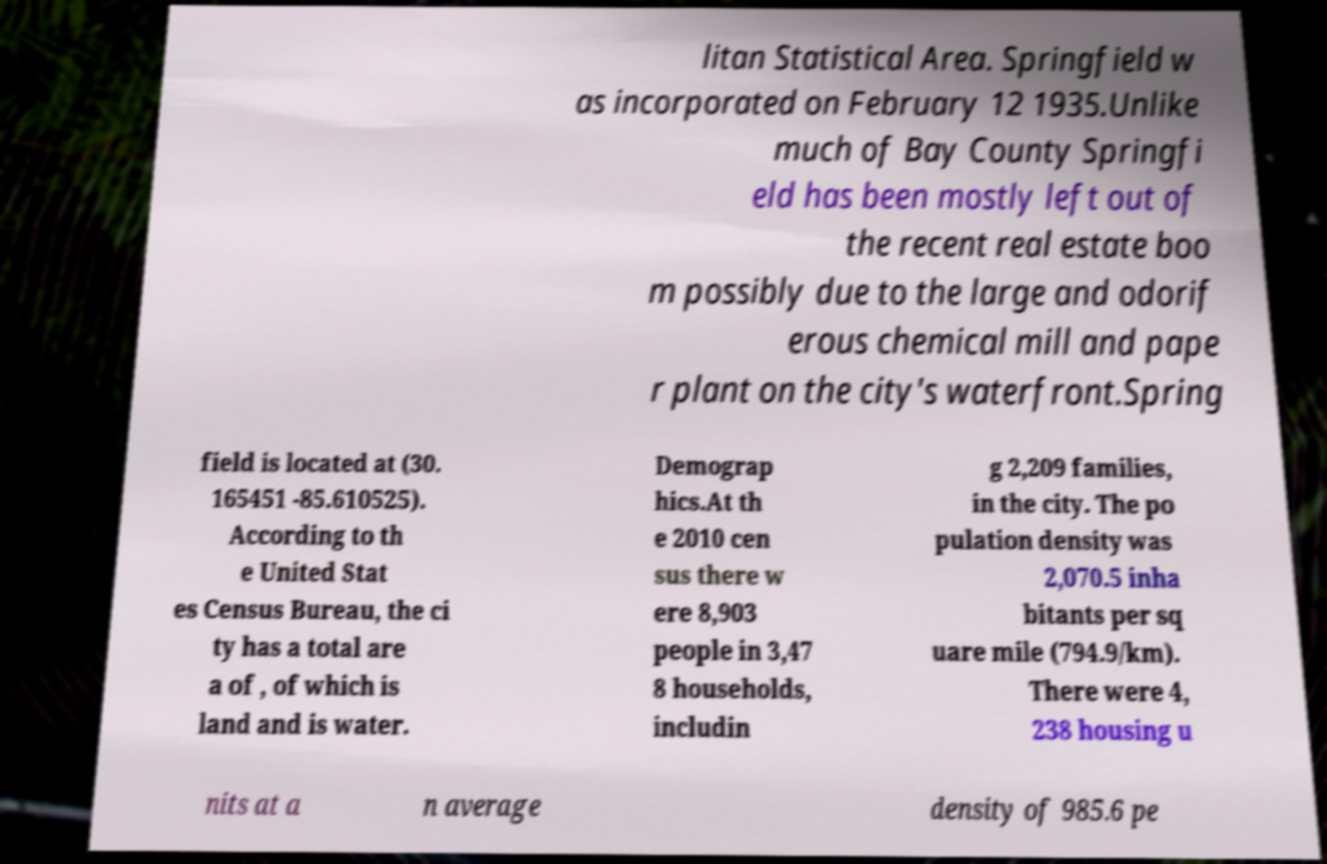Can you accurately transcribe the text from the provided image for me? litan Statistical Area. Springfield w as incorporated on February 12 1935.Unlike much of Bay County Springfi eld has been mostly left out of the recent real estate boo m possibly due to the large and odorif erous chemical mill and pape r plant on the city's waterfront.Spring field is located at (30. 165451 -85.610525). According to th e United Stat es Census Bureau, the ci ty has a total are a of , of which is land and is water. Demograp hics.At th e 2010 cen sus there w ere 8,903 people in 3,47 8 households, includin g 2,209 families, in the city. The po pulation density was 2,070.5 inha bitants per sq uare mile (794.9/km). There were 4, 238 housing u nits at a n average density of 985.6 pe 